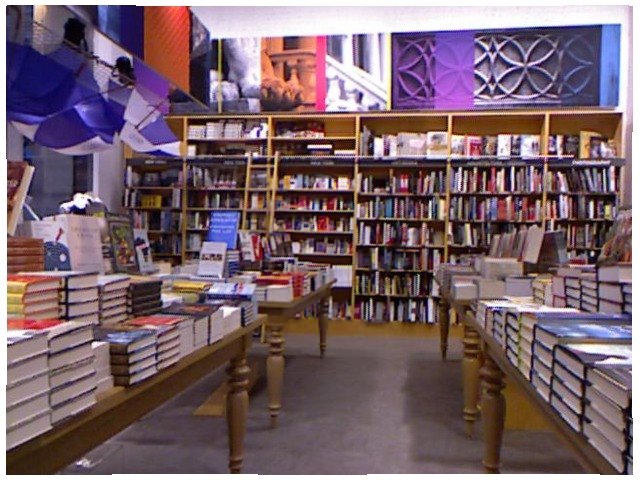<image>
Is there a book on the table? Yes. Looking at the image, I can see the book is positioned on top of the table, with the table providing support. 